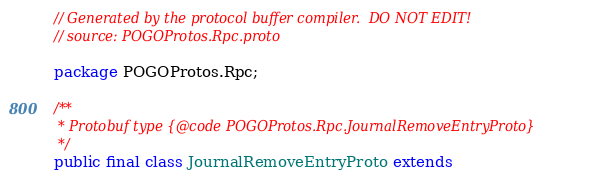Convert code to text. <code><loc_0><loc_0><loc_500><loc_500><_Java_>// Generated by the protocol buffer compiler.  DO NOT EDIT!
// source: POGOProtos.Rpc.proto

package POGOProtos.Rpc;

/**
 * Protobuf type {@code POGOProtos.Rpc.JournalRemoveEntryProto}
 */
public final class JournalRemoveEntryProto extends</code> 